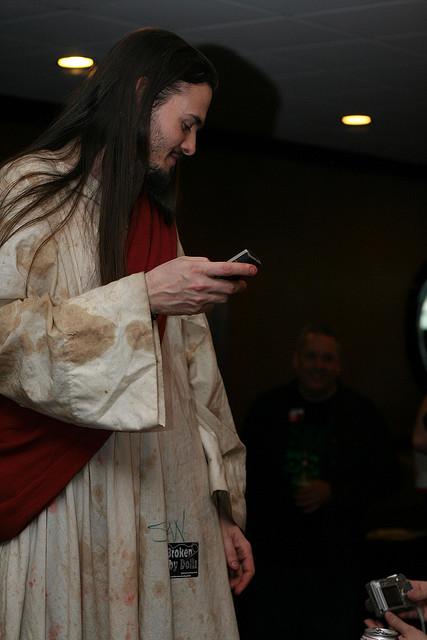Are his clothes dirty?
Write a very short answer. Yes. Does the man have a beard?
Write a very short answer. Yes. Who is this man dressed as?
Be succinct. Jesus. 